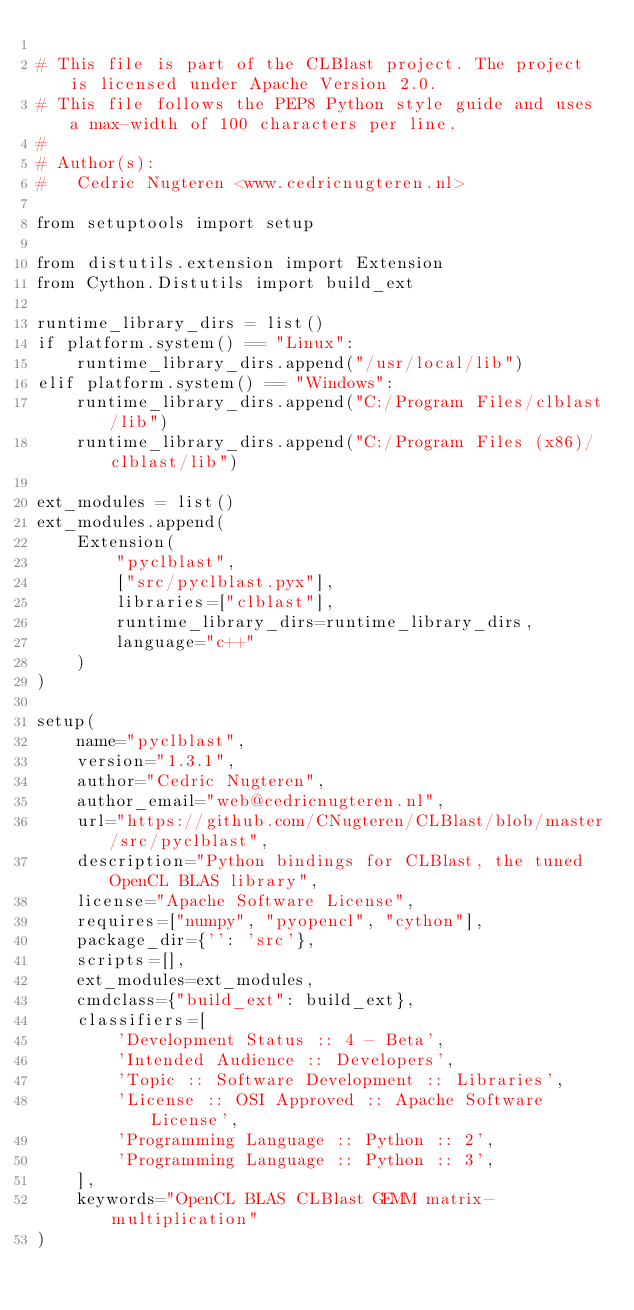Convert code to text. <code><loc_0><loc_0><loc_500><loc_500><_Python_>
# This file is part of the CLBlast project. The project is licensed under Apache Version 2.0.
# This file follows the PEP8 Python style guide and uses a max-width of 100 characters per line.
#
# Author(s):
#   Cedric Nugteren <www.cedricnugteren.nl>

from setuptools import setup

from distutils.extension import Extension
from Cython.Distutils import build_ext

runtime_library_dirs = list()
if platform.system() == "Linux":
    runtime_library_dirs.append("/usr/local/lib")
elif platform.system() == "Windows":
    runtime_library_dirs.append("C:/Program Files/clblast/lib")
    runtime_library_dirs.append("C:/Program Files (x86)/clblast/lib")

ext_modules = list()
ext_modules.append(
    Extension(
        "pyclblast",
        ["src/pyclblast.pyx"],
        libraries=["clblast"],
        runtime_library_dirs=runtime_library_dirs,
        language="c++"
    )
)

setup(
    name="pyclblast",
    version="1.3.1",
    author="Cedric Nugteren",
    author_email="web@cedricnugteren.nl",
    url="https://github.com/CNugteren/CLBlast/blob/master/src/pyclblast",
    description="Python bindings for CLBlast, the tuned OpenCL BLAS library",
    license="Apache Software License",
    requires=["numpy", "pyopencl", "cython"],
    package_dir={'': 'src'},
    scripts=[],
    ext_modules=ext_modules,
    cmdclass={"build_ext": build_ext},
    classifiers=[
        'Development Status :: 4 - Beta',
        'Intended Audience :: Developers',
        'Topic :: Software Development :: Libraries',
        'License :: OSI Approved :: Apache Software License',
        'Programming Language :: Python :: 2',
        'Programming Language :: Python :: 3',
    ],
    keywords="OpenCL BLAS CLBlast GEMM matrix-multiplication"
)
</code> 